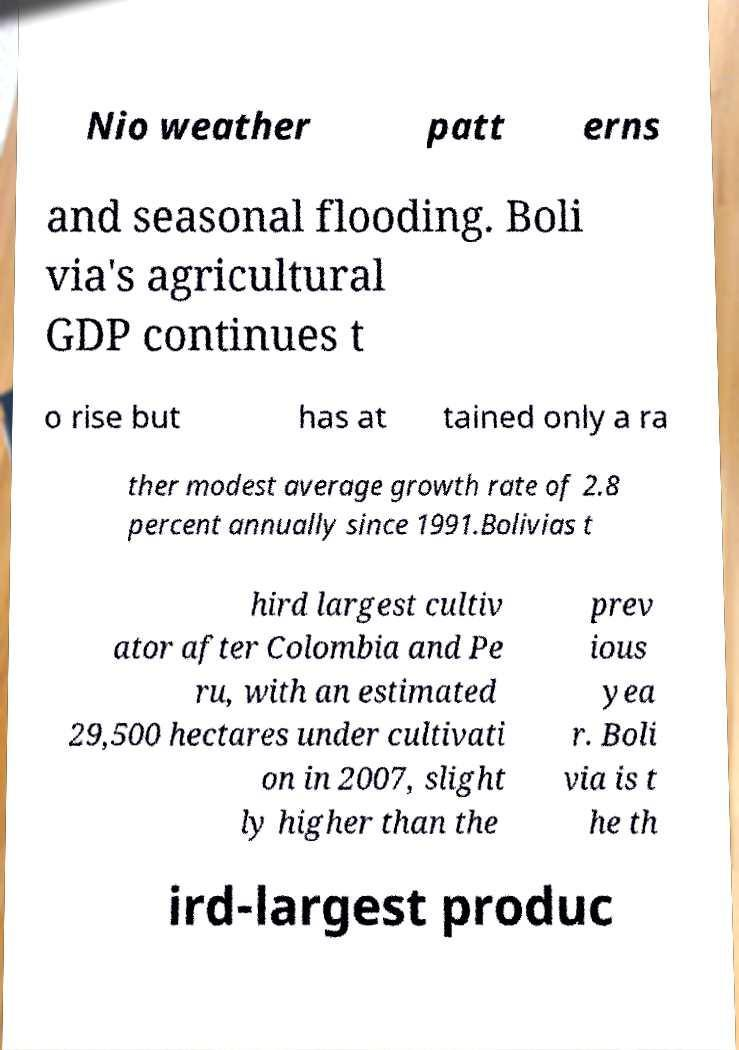Can you read and provide the text displayed in the image?This photo seems to have some interesting text. Can you extract and type it out for me? Nio weather patt erns and seasonal flooding. Boli via's agricultural GDP continues t o rise but has at tained only a ra ther modest average growth rate of 2.8 percent annually since 1991.Bolivias t hird largest cultiv ator after Colombia and Pe ru, with an estimated 29,500 hectares under cultivati on in 2007, slight ly higher than the prev ious yea r. Boli via is t he th ird-largest produc 